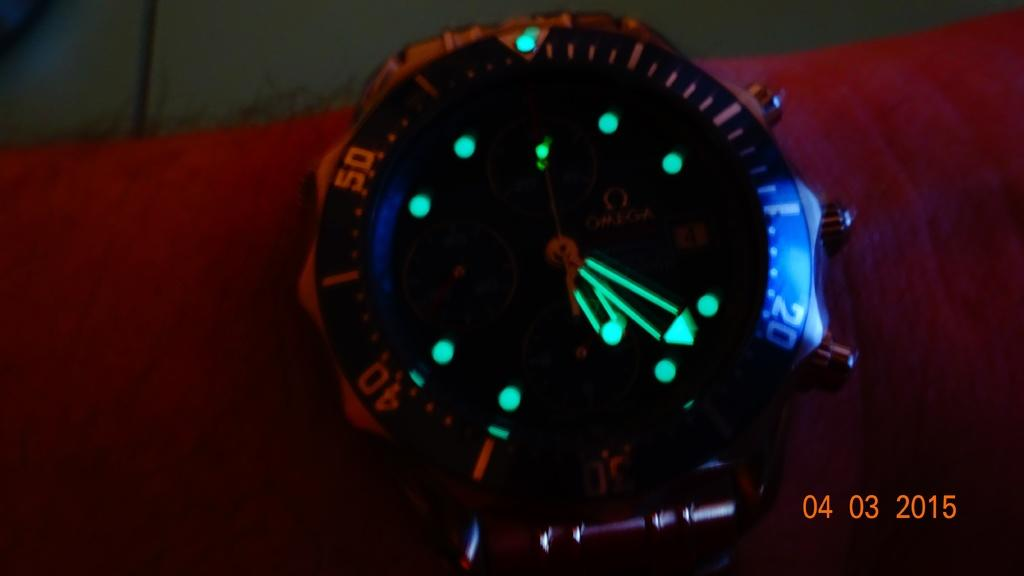<image>
Summarize the visual content of the image. A watch with glowing hands from a photo dated April 3, 2015. 